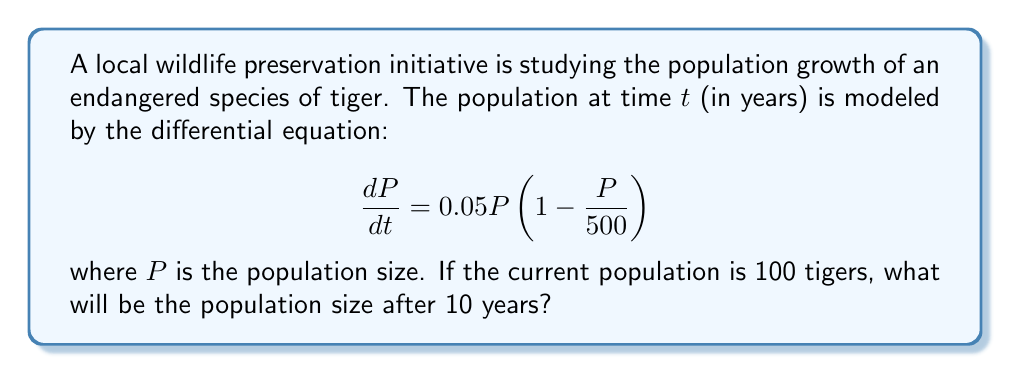Teach me how to tackle this problem. To solve this problem, we need to use the logistic growth model and solve the differential equation:

1) The given equation is a logistic growth model with growth rate $r = 0.05$ and carrying capacity $K = 500$.

2) The general solution to the logistic equation is:

   $$P(t) = \frac{KP_0}{P_0 + (K-P_0)e^{-rt}}$$

   where $P_0$ is the initial population.

3) We're given:
   $K = 500$
   $r = 0.05$
   $P_0 = 100$
   $t = 10$

4) Substituting these values into the solution:

   $$P(10) = \frac{500 \cdot 100}{100 + (500-100)e^{-0.05 \cdot 10}}$$

5) Simplify:
   $$P(10) = \frac{50000}{100 + 400e^{-0.5}}$$

6) Calculate $e^{-0.5} \approx 0.6065$

7) Substitute and calculate:
   $$P(10) = \frac{50000}{100 + 400(0.6065)} \approx 205.76$$

8) Since we're dealing with a whole number of tigers, we round to the nearest integer.
Answer: 206 tigers 